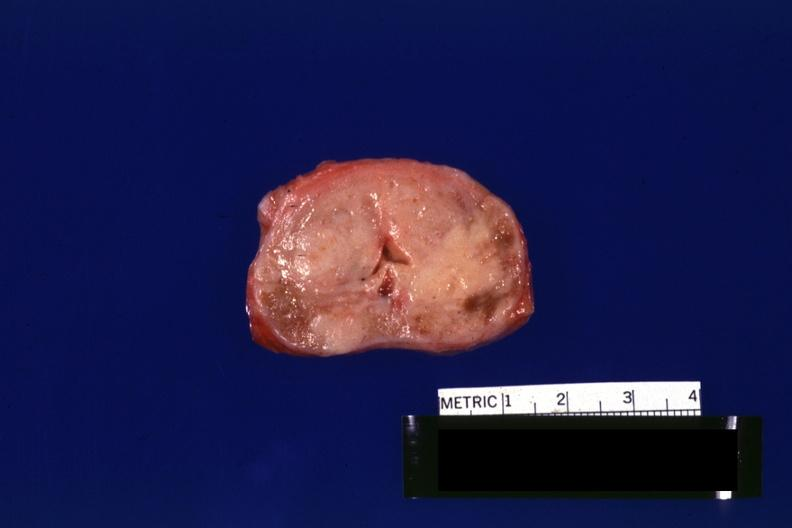s adenocarcinoma present?
Answer the question using a single word or phrase. Yes 